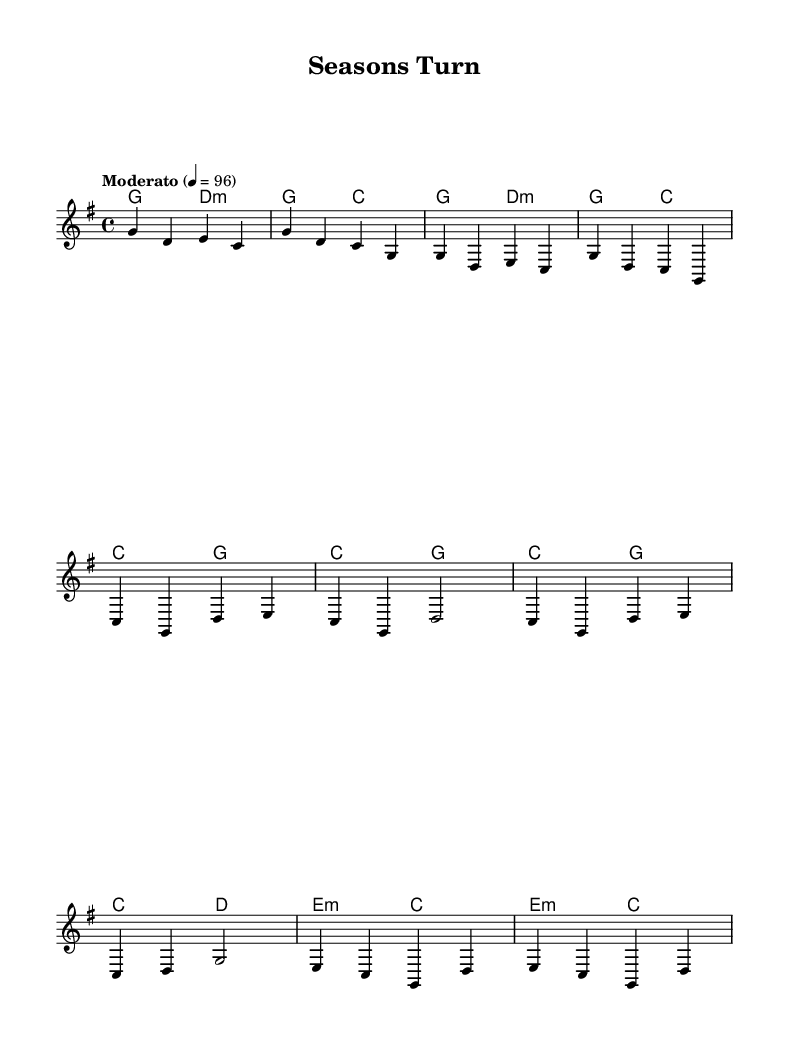What is the key signature of this music? The key signature is G major, which has one sharp (F#). This can be identified by locating the key signature symbols, which appear at the beginning of the staff.
Answer: G major What is the time signature of this music? The time signature is 4/4, indicated at the beginning of the piece. The "4" on the top indicates there are four beats in each measure, and the "4" on the bottom indicates that a quarter note gets one beat.
Answer: 4/4 What is the tempo marking for this piece? The tempo marking is "Moderato," and it indicates a moderate pace. The numerical indication "4 = 96" means there are 96 beats per minute, with each quarter note counted as one beat.
Answer: Moderato How many measures are in the full score as presented? To count the measures, we look at the music and find vertical lines that divide the music into sections. By counting those lines, we find there are 12 measures.
Answer: 12 What chords are used in the chorus section? The chords in the chorus section include C major and G major. By observing the chord symbols above the staff during the chorus segment, we can identify the chords played alongside the melody.
Answer: C major, G major Explain the structure of the piece based on sections. The piece consists of several sections: an intro, a verse (partial), a chorus, and a bridge (partial). The intro sets the theme, the verse elaborates on the melodies, the chorus serves as the main thematic statement, and the bridge provides contrast. This structure aligns with common folk song formats, allowing for a narrative progression through the changing seasons.
Answer: Intro, Verse, Chorus, Bridge 